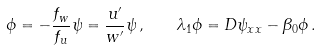<formula> <loc_0><loc_0><loc_500><loc_500>\phi = - \frac { f _ { w } } { f _ { u } } \psi = \frac { u ^ { \prime } } { w ^ { \prime } } \psi \, , \quad \lambda _ { 1 } \phi = D \psi _ { x x } - \beta _ { 0 } \phi \, .</formula> 